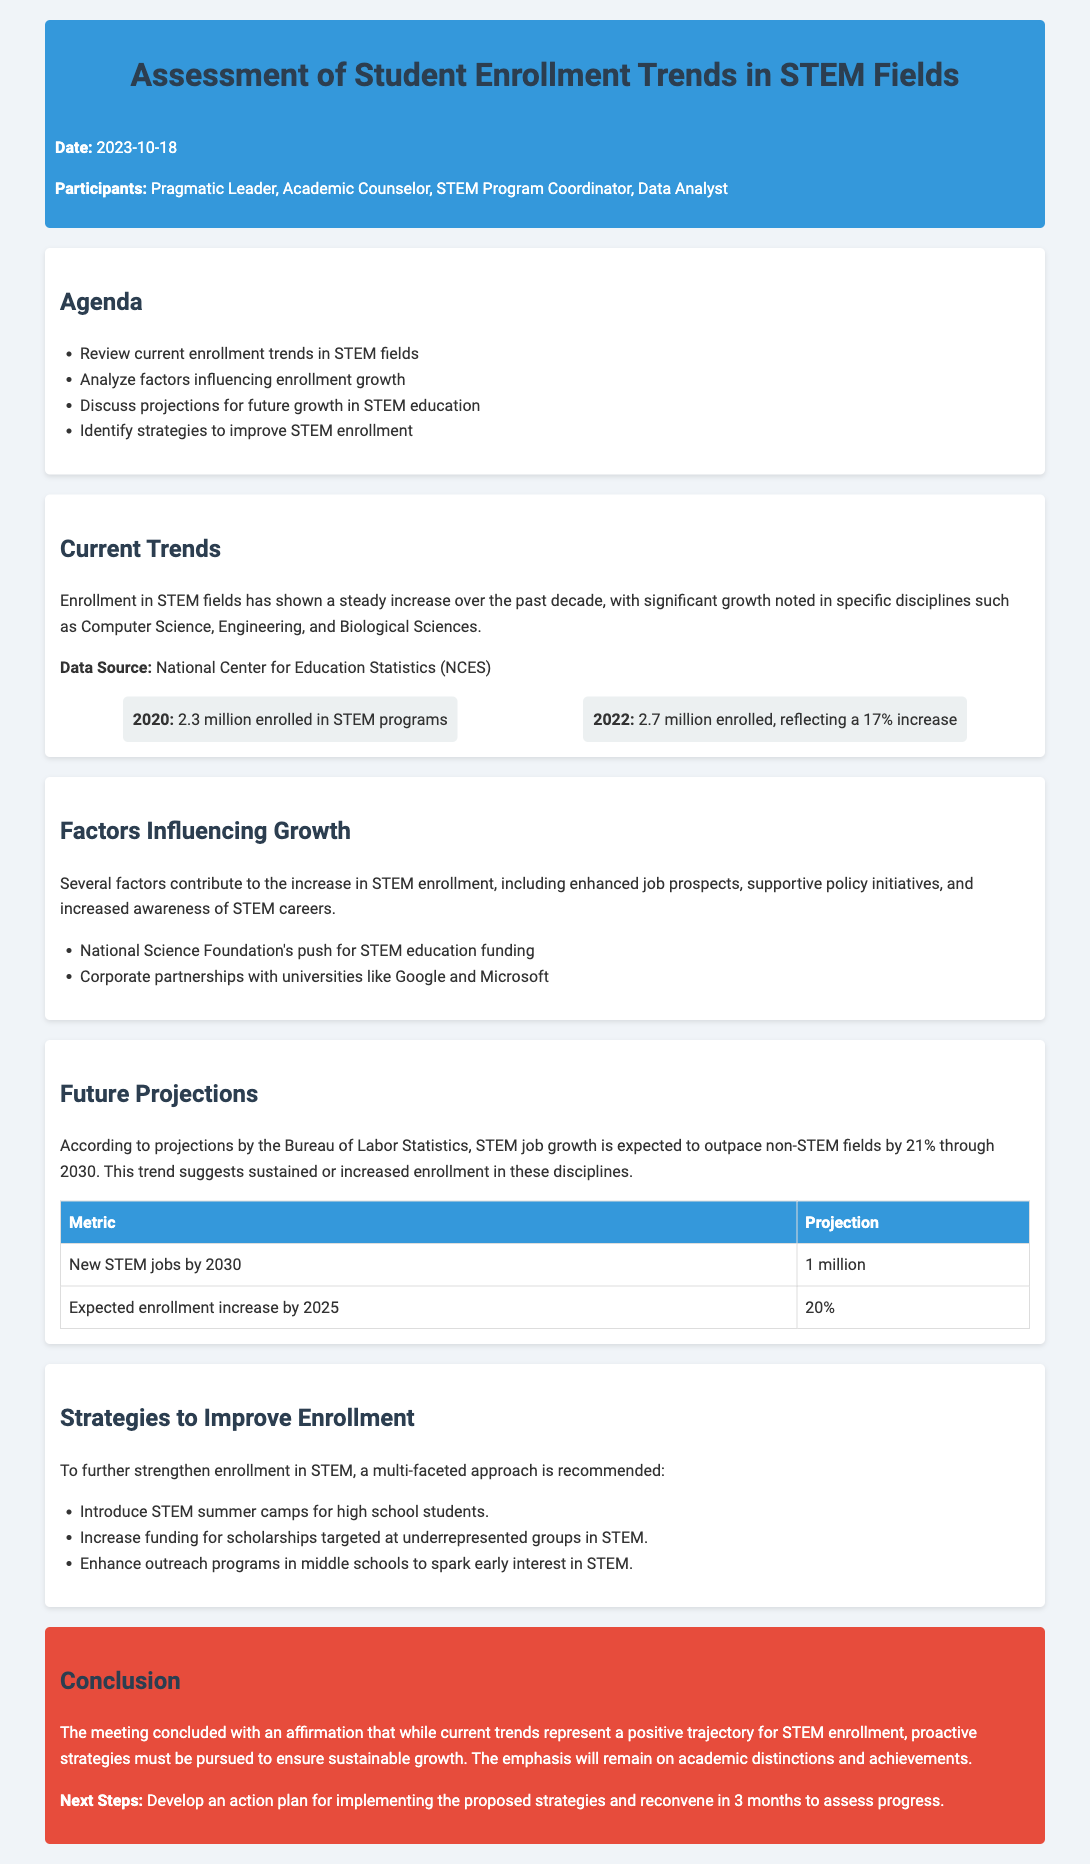what date was the meeting held? The date of the meeting is provided in the document header.
Answer: 2023-10-18 who is the primary participant listed in the meeting? The primary participant is mentioned as the Pragmatic Leader in the participants section.
Answer: Pragmatic Leader what was the enrollment in STEM programs in 2022? The document states the enrollment figure for 2022 under current trends.
Answer: 2.7 million what is the projected increase in STEM jobs by 2030? The projection for new STEM jobs by 2030 is stated in the future projections section of the document.
Answer: 1 million which organization provides funding for STEM education according to the document? The document mentions the National Science Foundation in relation to STEM education funding.
Answer: National Science Foundation what is the expected enrollment increase percentage by 2025? The expected enrollment increase percentage is detailed in the future projections section.
Answer: 20% which strategies are suggested to improve STEM enrollment? The document outlines several strategies under the section for improving enrollment in STEM.
Answer: STEM summer camps, scholarships, outreach programs what was the percentage increase in STEM enrollment from 2020 to 2022? The document provides a percentage for this increase in its current trends section.
Answer: 17% what will be discussed in the next meeting? The conclusion mentions the next steps that will occur in the following meeting.
Answer: Assess progress 